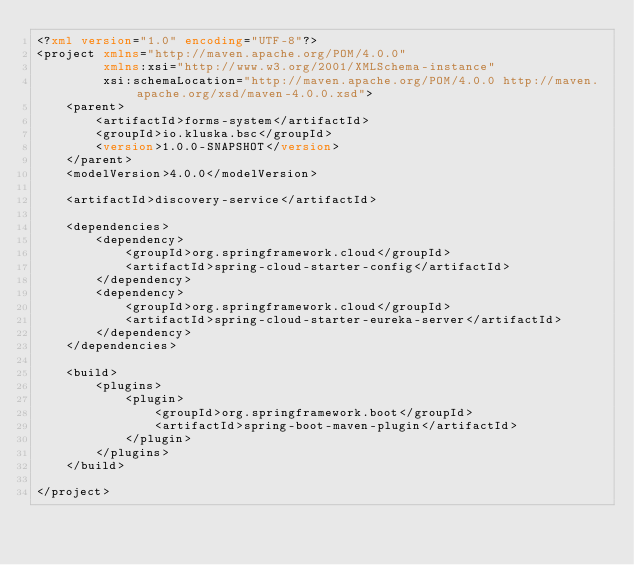Convert code to text. <code><loc_0><loc_0><loc_500><loc_500><_XML_><?xml version="1.0" encoding="UTF-8"?>
<project xmlns="http://maven.apache.org/POM/4.0.0"
         xmlns:xsi="http://www.w3.org/2001/XMLSchema-instance"
         xsi:schemaLocation="http://maven.apache.org/POM/4.0.0 http://maven.apache.org/xsd/maven-4.0.0.xsd">
    <parent>
        <artifactId>forms-system</artifactId>
        <groupId>io.kluska.bsc</groupId>
        <version>1.0.0-SNAPSHOT</version>
    </parent>
    <modelVersion>4.0.0</modelVersion>

    <artifactId>discovery-service</artifactId>

    <dependencies>
        <dependency>
            <groupId>org.springframework.cloud</groupId>
            <artifactId>spring-cloud-starter-config</artifactId>
        </dependency>
        <dependency>
            <groupId>org.springframework.cloud</groupId>
            <artifactId>spring-cloud-starter-eureka-server</artifactId>
        </dependency>
    </dependencies>

    <build>
        <plugins>
            <plugin>
                <groupId>org.springframework.boot</groupId>
                <artifactId>spring-boot-maven-plugin</artifactId>
            </plugin>
        </plugins>
    </build>

</project></code> 